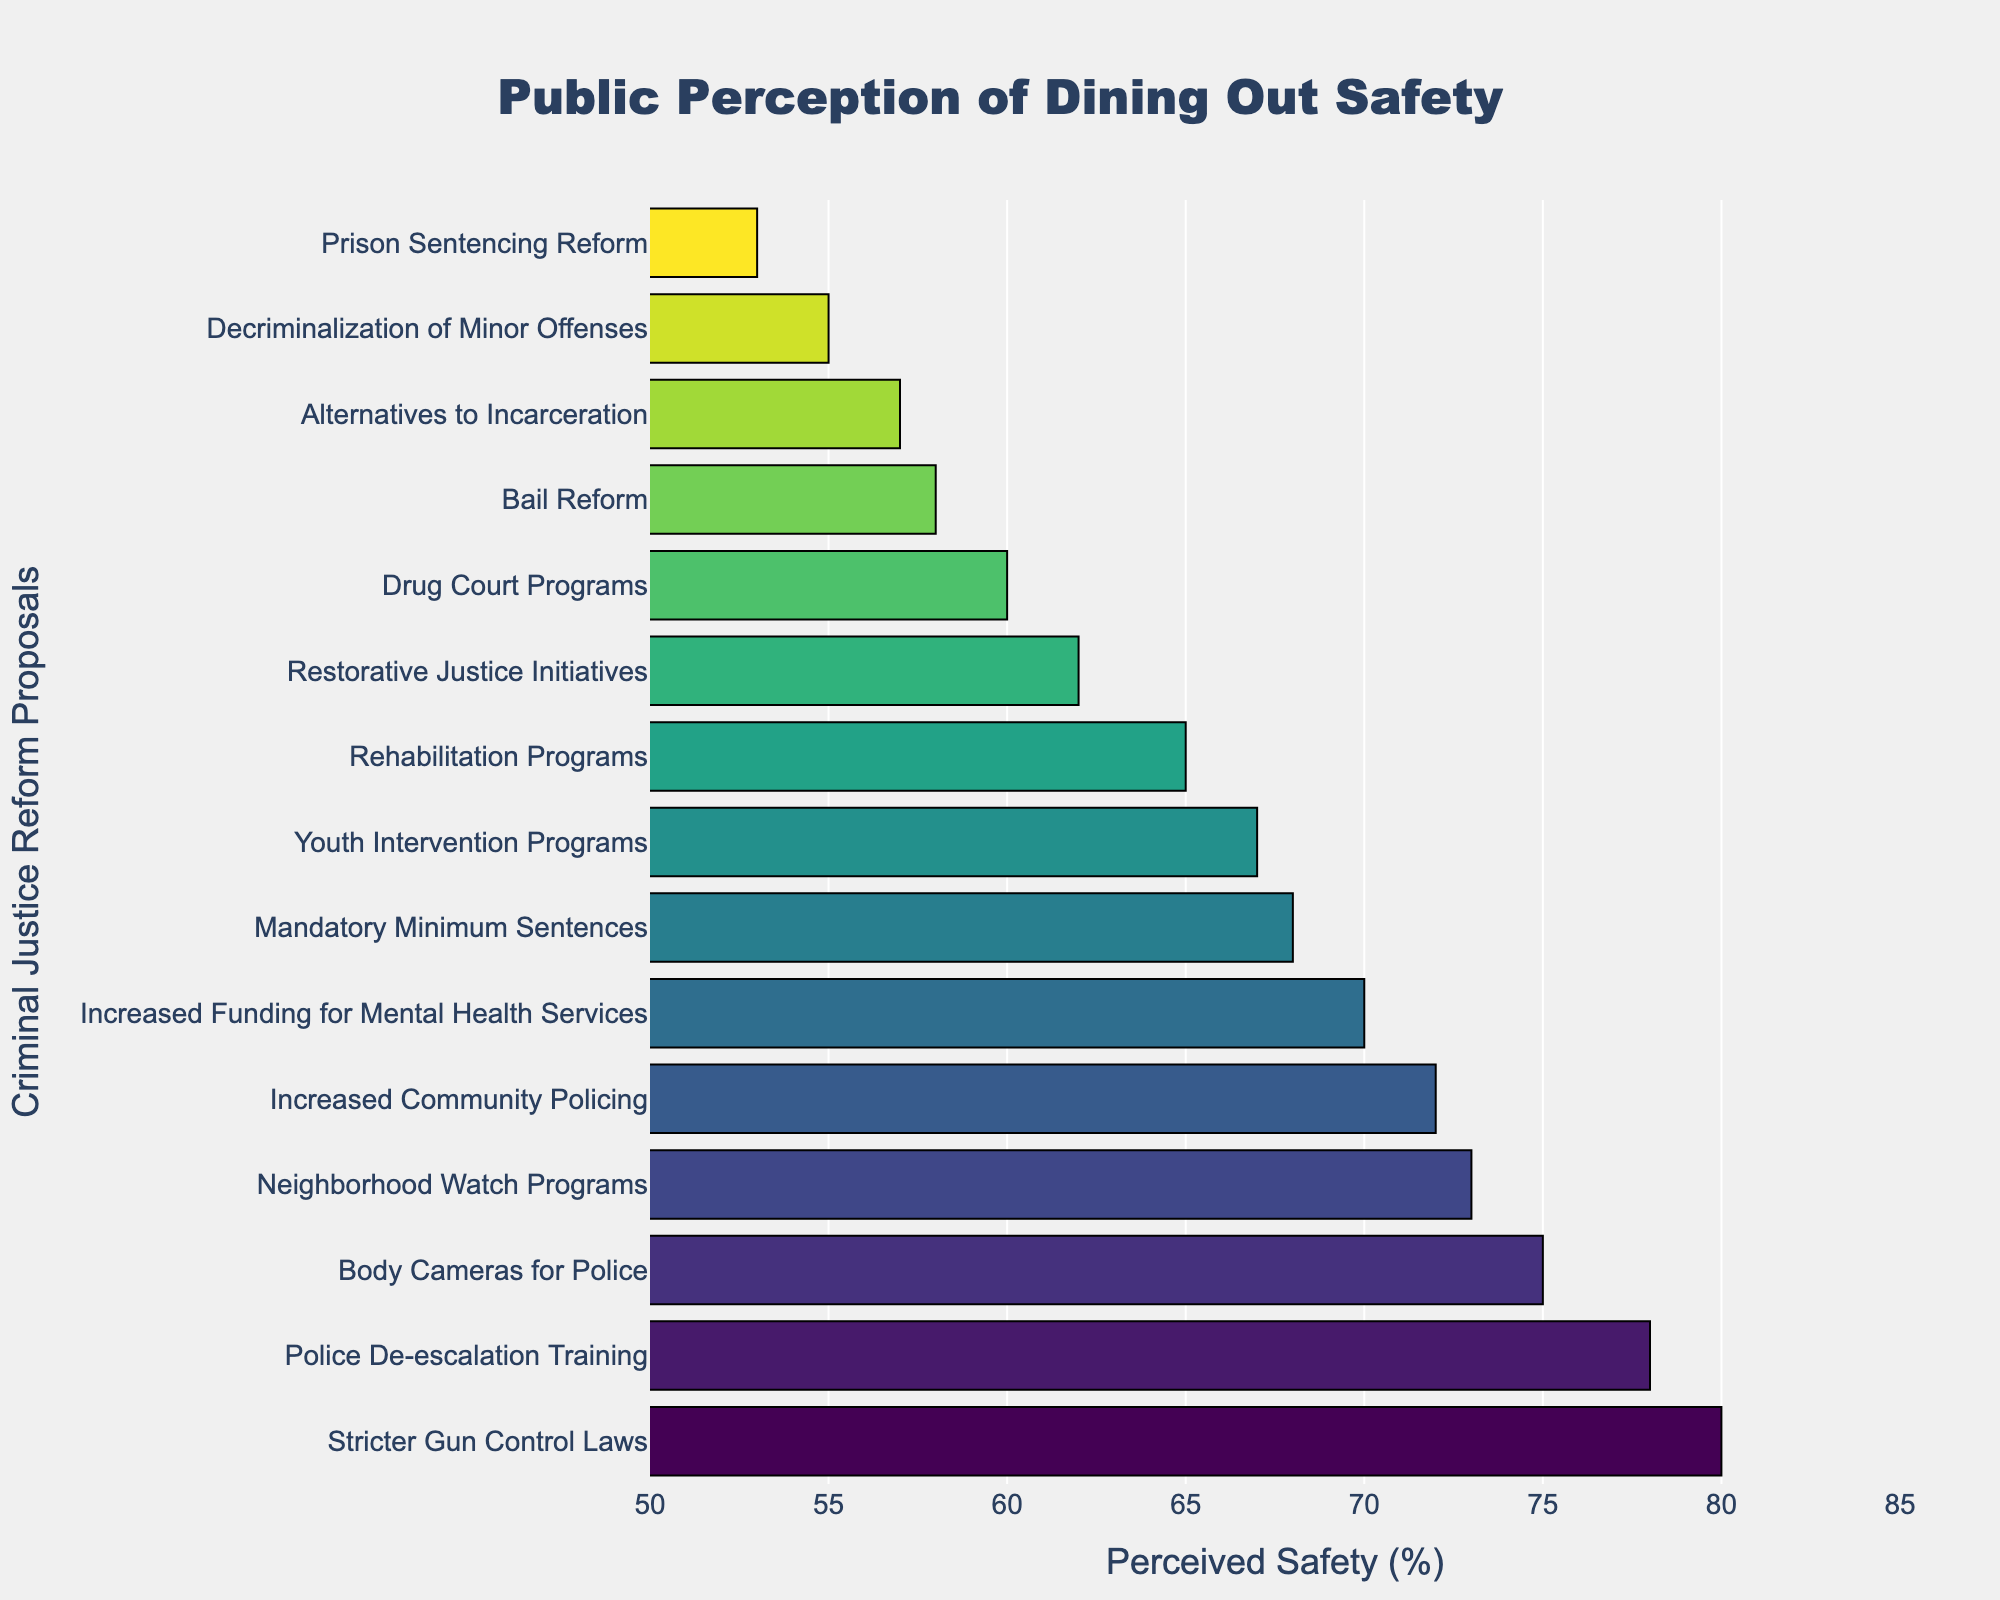What's the policy with the highest perceived safety percentage? The policy with the highest perceived safety percentage is identified by finding the bar with the longest length in the plot.
Answer: Stricter Gun Control Laws Which two policies have a perceived safety percentage greater than 70% but less than or equal to 75%? Look for bars whose lengths correspond to percentages in the specified range.
Answer: Body Cameras for Police and Neighborhood Watch Programs What is the difference in perceived safety percentage between 'Increased Community Policing' and 'Prison Sentencing Reform'? The perceived safety for 'Increased Community Policing' is 72%, and for 'Prison Sentencing Reform' it is 53%. Calculate the difference: 72% - 53%.
Answer: 19% Which policy ranks second in perceived safety percentage? After identifying the highest bar, the second highest bar corresponds to the policy with the second highest perceived safety percentage.
Answer: Police De-escalation Training What is the average perceived safety percentage of 'Youth Intervention Programs', 'Restorative Justice Initiatives', and 'Drug Court Programs'? Add the percentages of these three policies and divide by 3: (67 + 62 + 60) / 3.
Answer: 63% Which policies are perceived to have a safety percentage within 5% of the 'Bail Reform' policy? 'Bail Reform' has a perceived safety of 58%. Policies within 5% of this value range from 53% to 63%. Identify the policies that fall into this range.
Answer: Prison Sentencing Reform, Decriminalization of Minor Offenses, Drug Court Programs, Restorative Justice Initiatives, Alternatives to Incarceration How many policies have a perceived safety percentage above 65%? Count the number of bars that extend beyond the 65% mark on the x-axis.
Answer: 6 Is the perceived safety percentage of 'Increased Funding for Mental Health Services' higher or lower than the perceived safety percentage of 'Youth Intervention Programs'? Compare the lengths of the bars for these two policies.
Answer: Higher What is the combined perceived safety percentage of the three lowest-rated policies? Identify the three shortest bars and sum their percentages: 'Prison Sentencing Reform' (53%), 'Decriminalization of Minor Offenses' (55%), and 'Bail Reform' (58%).
Answer: 166% Which policy has the highest perceived safety percentage that is not related to policing measures? Identify the highest bar among the policies that do not involve policing.
Answer: Stricter Gun Control Laws 